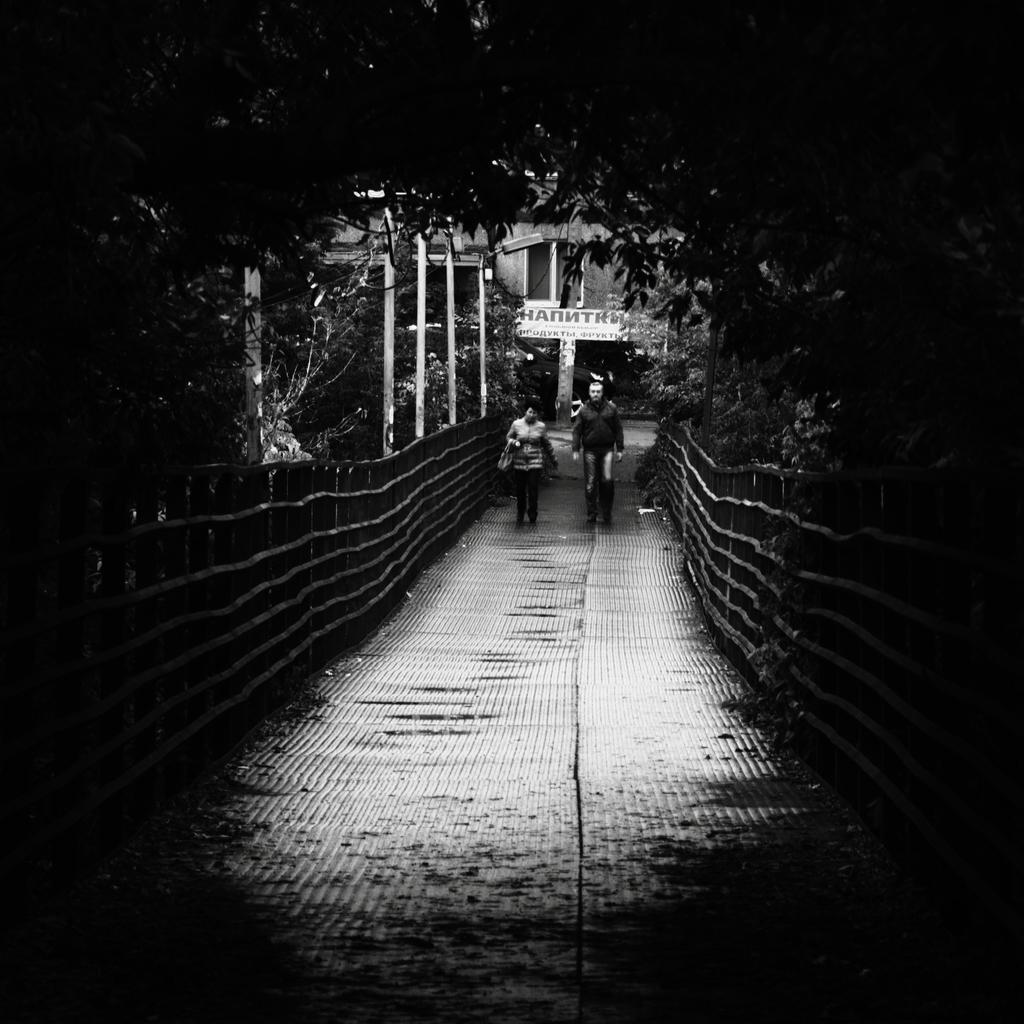What structure can be seen in the image? There is a bridge in the image. Are there any people on the bridge? Yes, two persons are on the bridge. What type of natural environment can be seen in the image? There are trees visible in the image. What type of man-made structures can be seen in the image? There is at least one building and some poles in the image. What time of day was the image taken? The image was taken during nighttime. What type of lunch is the spy eating on the bridge in the image? There is no indication of a spy or lunch in the image; it only shows two persons on a bridge, trees, buildings, and poles. 